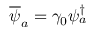<formula> <loc_0><loc_0><loc_500><loc_500>\overline { \psi } _ { a } = \gamma _ { 0 } \psi _ { a } ^ { \dagger }</formula> 